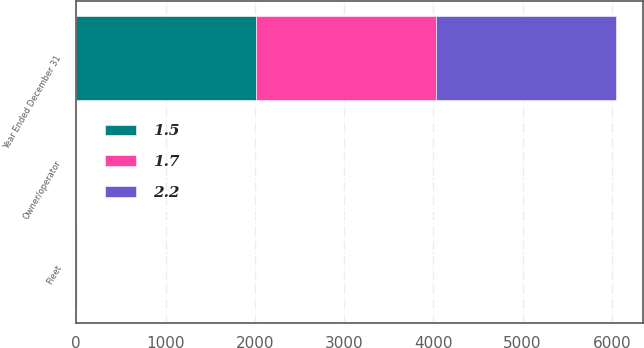<chart> <loc_0><loc_0><loc_500><loc_500><stacked_bar_chart><ecel><fcel>Year Ended December 31<fcel>Fleet<fcel>Owner/operator<nl><fcel>1.5<fcel>2018<fcel>2<fcel>0.2<nl><fcel>1.7<fcel>2017<fcel>1.6<fcel>0.1<nl><fcel>2.2<fcel>2016<fcel>1.1<fcel>0.4<nl></chart> 